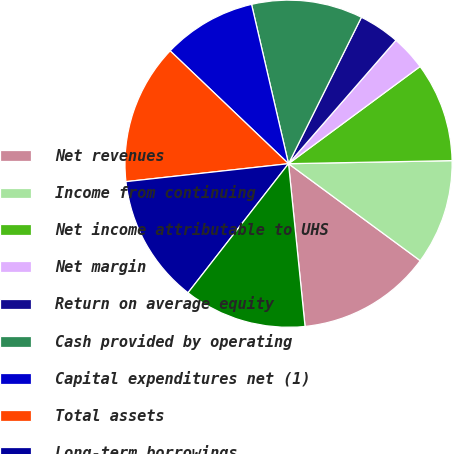Convert chart. <chart><loc_0><loc_0><loc_500><loc_500><pie_chart><fcel>Net revenues<fcel>Income from continuing<fcel>Net income attributable to UHS<fcel>Net margin<fcel>Return on average equity<fcel>Cash provided by operating<fcel>Capital expenditures net (1)<fcel>Total assets<fcel>Long-term borrowings<fcel>UHS's common stockholders'<nl><fcel>13.29%<fcel>10.4%<fcel>9.83%<fcel>3.47%<fcel>4.05%<fcel>10.98%<fcel>9.25%<fcel>13.87%<fcel>12.72%<fcel>12.14%<nl></chart> 